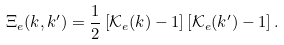<formula> <loc_0><loc_0><loc_500><loc_500>\Xi _ { e } ( k , k ^ { \prime } ) = \frac { 1 } { 2 } \left [ \mathcal { K } _ { e } ( k ) - 1 \right ] \left [ \mathcal { K } _ { e } ( k ^ { \prime } ) - 1 \right ] .</formula> 